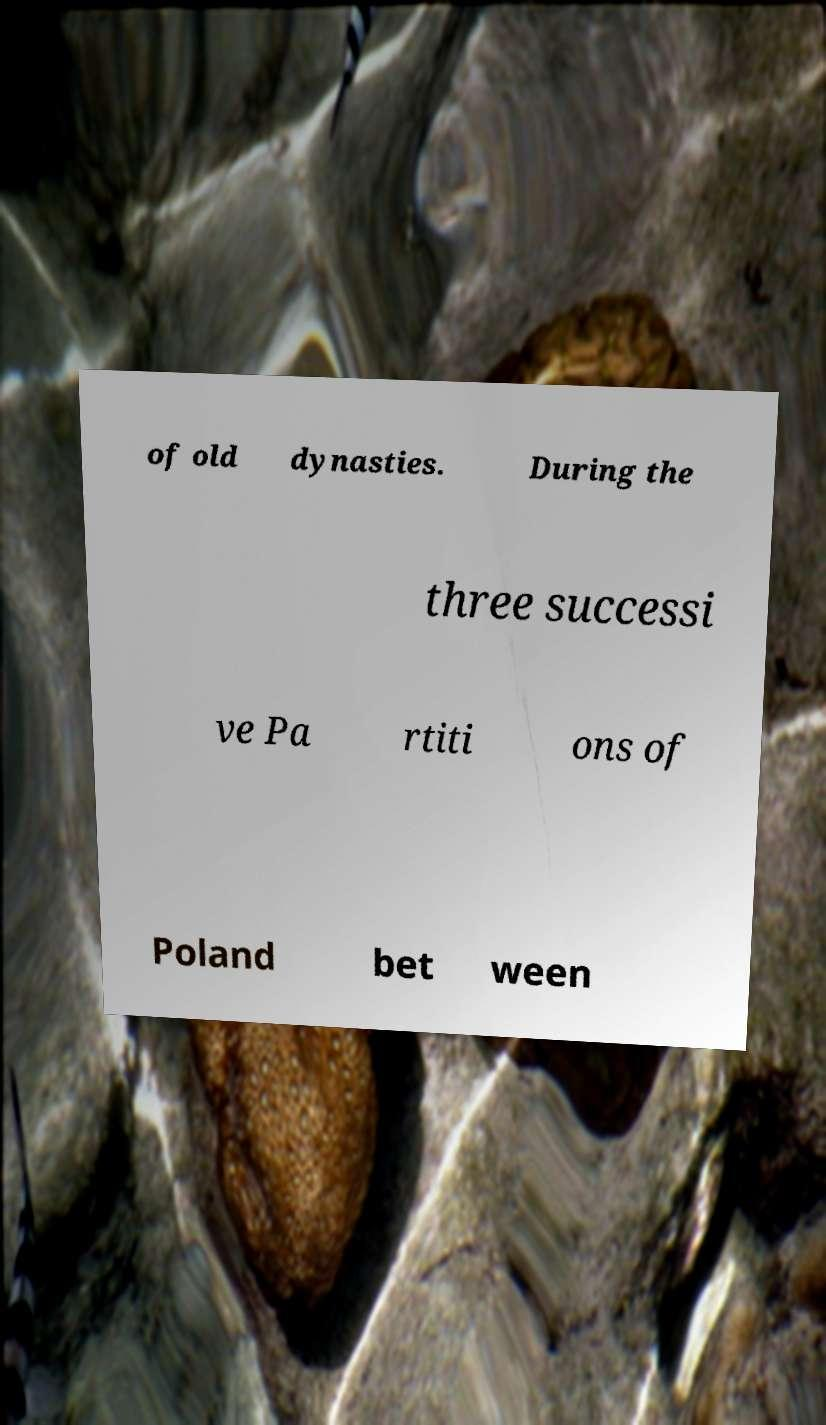Could you assist in decoding the text presented in this image and type it out clearly? of old dynasties. During the three successi ve Pa rtiti ons of Poland bet ween 